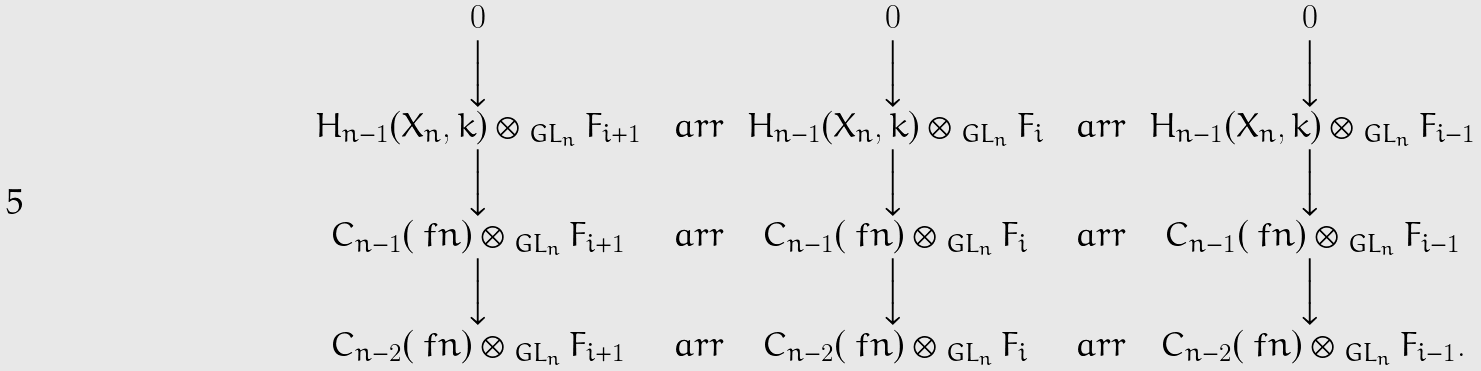<formula> <loc_0><loc_0><loc_500><loc_500>\begin{array} { c c c c c } 0 & & 0 & & 0 \\ \Big \downarrow & & \Big \downarrow & & \Big \downarrow \\ H _ { n - 1 } ( X _ { n } , k ) \otimes _ { \ G L _ { n } } F _ { i + 1 } & \, \ a r r & \, H _ { n - 1 } ( X _ { n } , k ) \otimes _ { \ G L _ { n } } F _ { i } & \, \ a r r & \, H _ { n - 1 } ( X _ { n } , k ) \otimes _ { \ G L _ { n } } F _ { i - 1 } \\ \Big \downarrow & & \Big \downarrow & & \Big \downarrow \\ C _ { n - 1 } ( \ f n ) \otimes _ { \ G L _ { n } } F _ { i + 1 } & \, \ a r r & \, C _ { n - 1 } ( \ f n ) \otimes _ { \ G L _ { n } } F _ { i } & \, \ a r r & \, C _ { n - 1 } ( \ f n ) \otimes _ { \ G L _ { n } } F _ { i - 1 } \\ \Big \downarrow & & \Big \downarrow & & \Big \downarrow \\ C _ { n - 2 } ( \ f n ) \otimes _ { \ G L _ { n } } F _ { i + 1 } & \, \ a r r & \, C _ { n - 2 } ( \ f n ) \otimes _ { \ G L _ { n } } F _ { i } & \, \ a r r & \, C _ { n - 2 } ( \ f n ) \otimes _ { \ G L _ { n } } F _ { i - 1 } . \\ & & & & \end{array}</formula> 